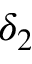<formula> <loc_0><loc_0><loc_500><loc_500>\delta _ { 2 }</formula> 